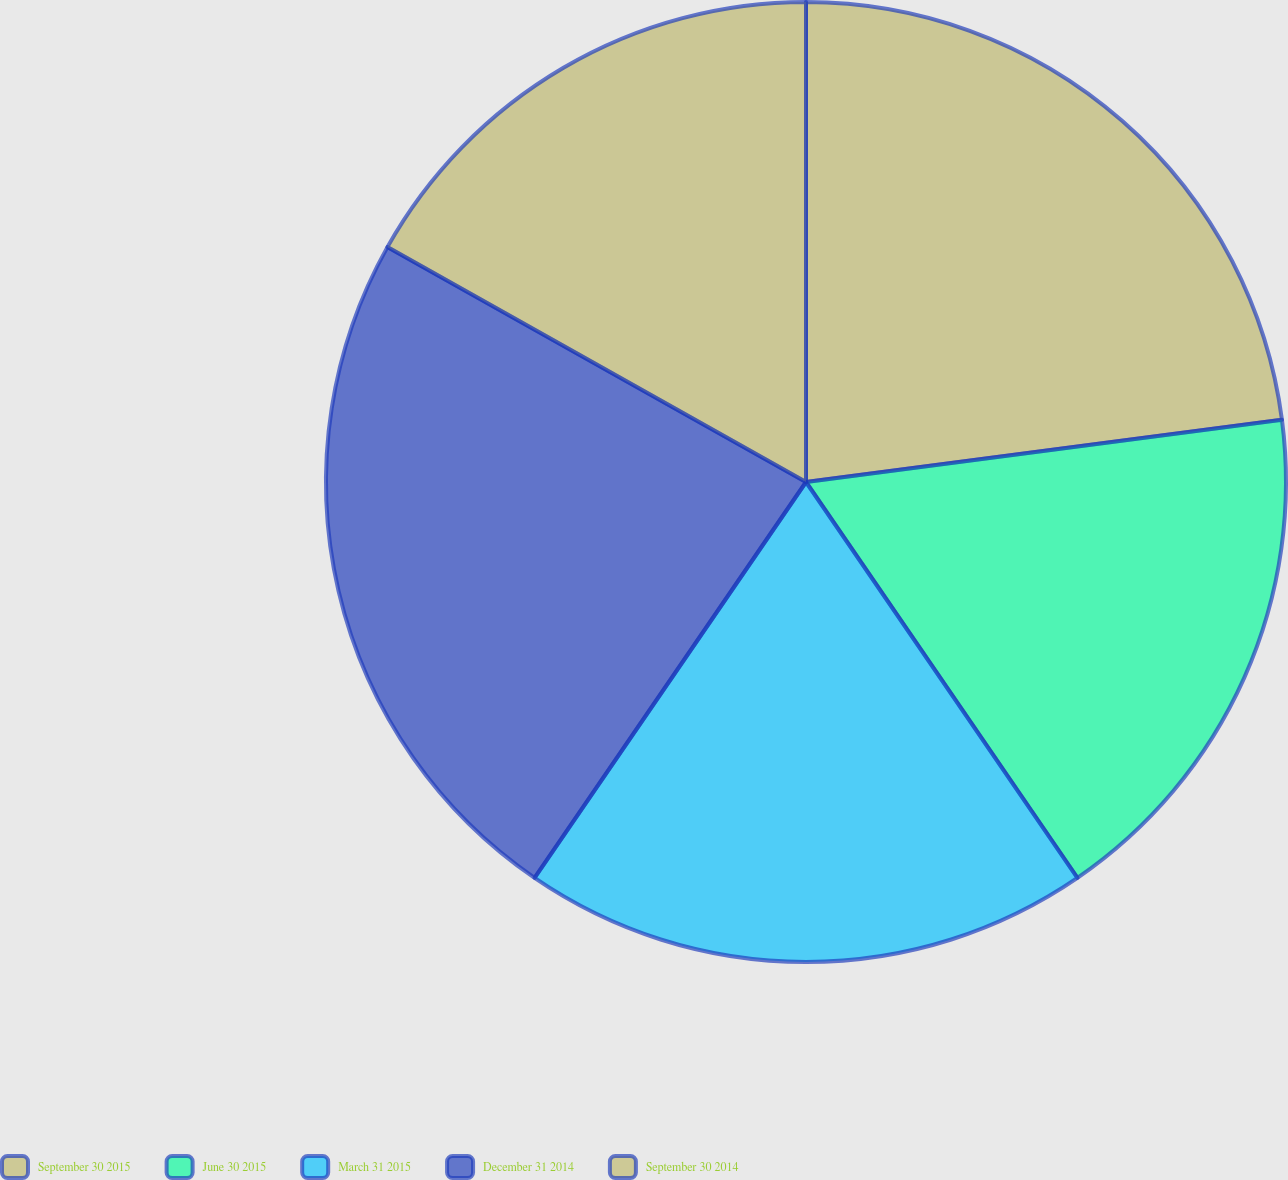<chart> <loc_0><loc_0><loc_500><loc_500><pie_chart><fcel>September 30 2015<fcel>June 30 2015<fcel>March 31 2015<fcel>December 31 2014<fcel>September 30 2014<nl><fcel>22.93%<fcel>17.5%<fcel>19.13%<fcel>23.57%<fcel>16.86%<nl></chart> 